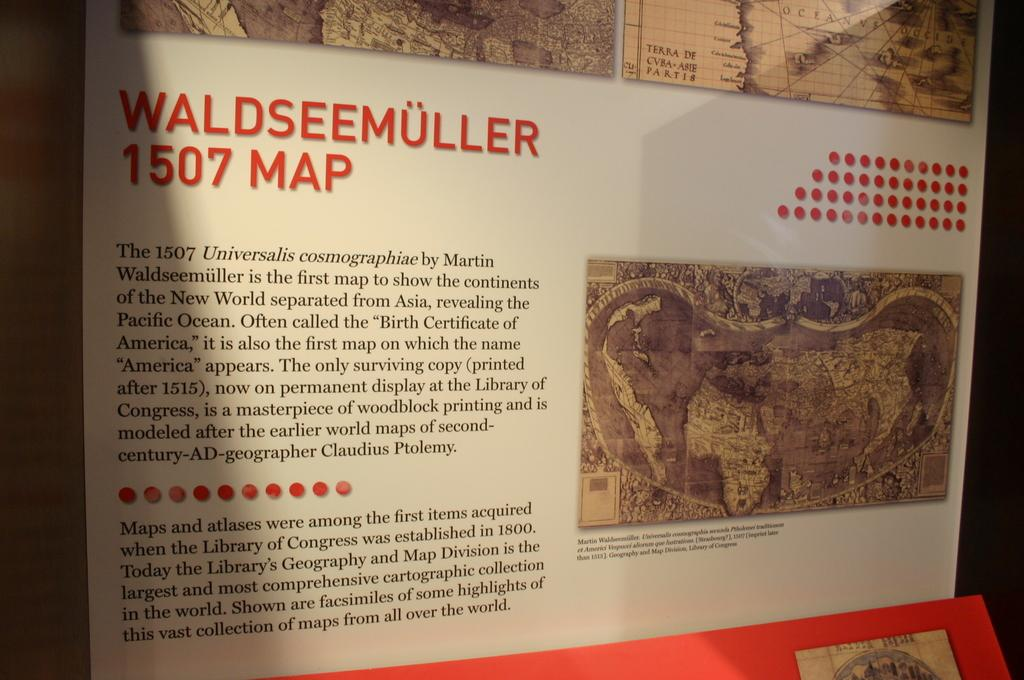Provide a one-sentence caption for the provided image. A map depicting Waldseemuller in 1507 with a text description. 